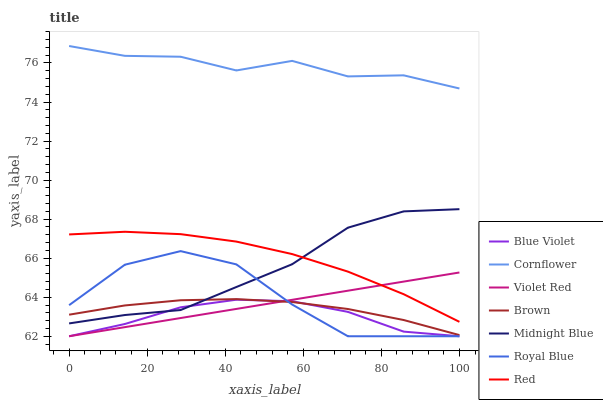Does Violet Red have the minimum area under the curve?
Answer yes or no. No. Does Violet Red have the maximum area under the curve?
Answer yes or no. No. Is Midnight Blue the smoothest?
Answer yes or no. No. Is Midnight Blue the roughest?
Answer yes or no. No. Does Midnight Blue have the lowest value?
Answer yes or no. No. Does Violet Red have the highest value?
Answer yes or no. No. Is Brown less than Red?
Answer yes or no. Yes. Is Cornflower greater than Violet Red?
Answer yes or no. Yes. Does Brown intersect Red?
Answer yes or no. No. 